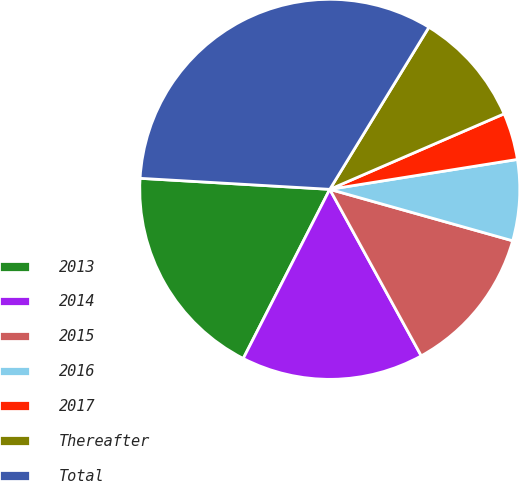<chart> <loc_0><loc_0><loc_500><loc_500><pie_chart><fcel>2013<fcel>2014<fcel>2015<fcel>2016<fcel>2017<fcel>Thereafter<fcel>Total<nl><fcel>18.4%<fcel>15.52%<fcel>12.64%<fcel>6.88%<fcel>3.99%<fcel>9.76%<fcel>32.81%<nl></chart> 